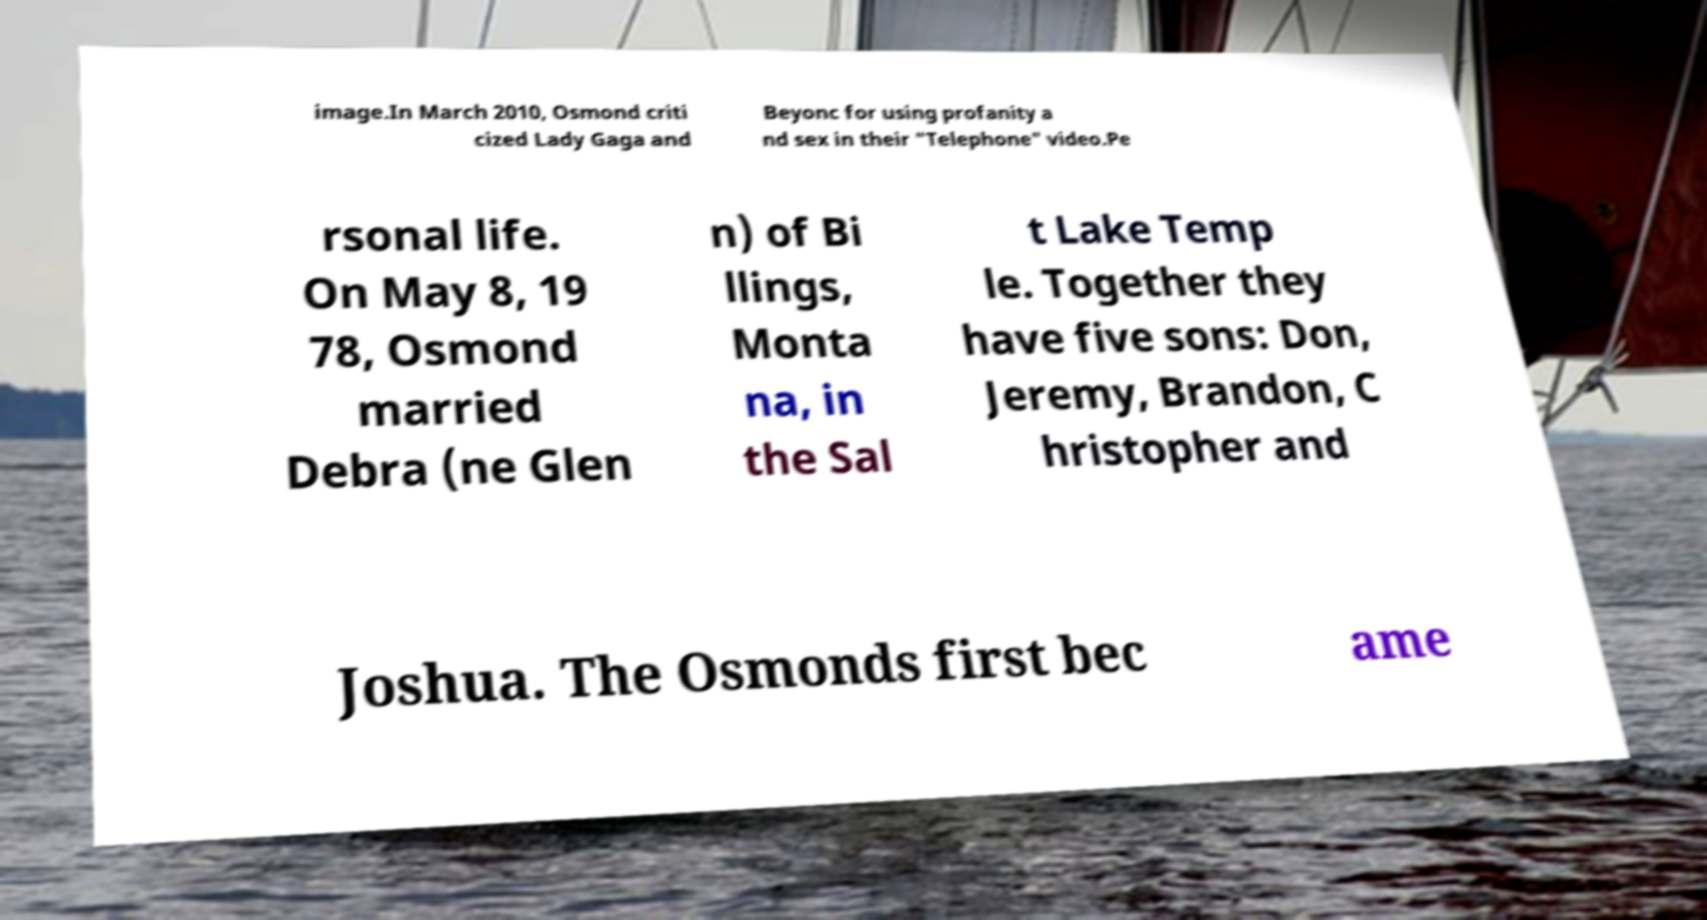For documentation purposes, I need the text within this image transcribed. Could you provide that? image.In March 2010, Osmond criti cized Lady Gaga and Beyonc for using profanity a nd sex in their "Telephone" video.Pe rsonal life. On May 8, 19 78, Osmond married Debra (ne Glen n) of Bi llings, Monta na, in the Sal t Lake Temp le. Together they have five sons: Don, Jeremy, Brandon, C hristopher and Joshua. The Osmonds first bec ame 